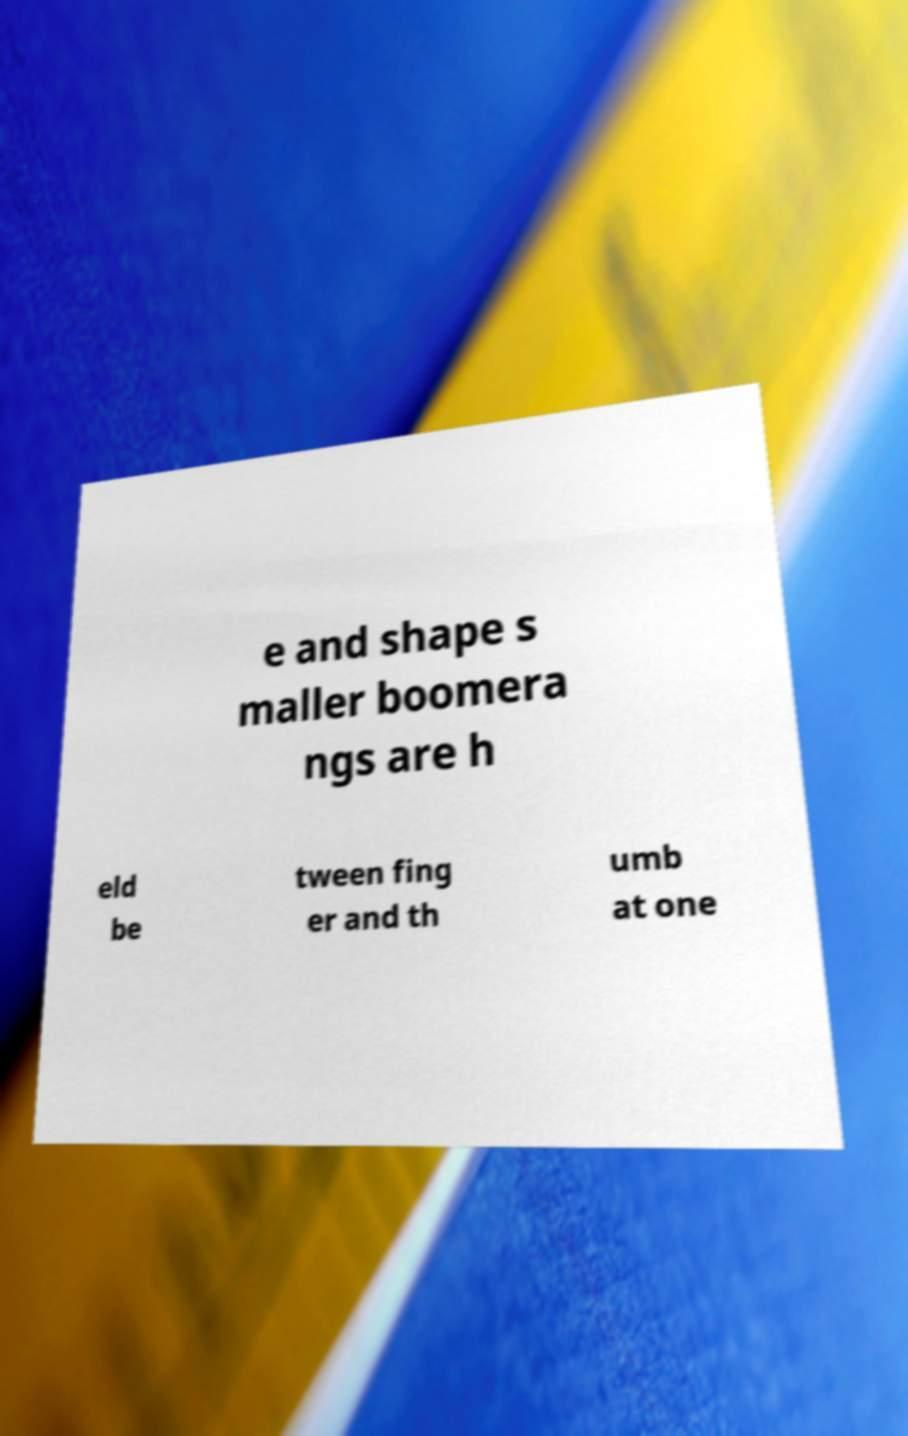Could you assist in decoding the text presented in this image and type it out clearly? e and shape s maller boomera ngs are h eld be tween fing er and th umb at one 